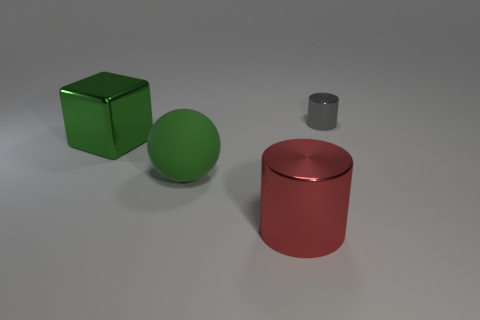The other thing that is the same color as the big rubber thing is what shape?
Ensure brevity in your answer.  Cube. There is a rubber ball; is its color the same as the large metal object behind the large sphere?
Provide a short and direct response. Yes. How many other things are the same size as the matte object?
Your response must be concise. 2. Do the thing that is to the right of the red cylinder and the green rubber object have the same shape?
Ensure brevity in your answer.  No. Is the number of metallic blocks that are on the left side of the green rubber object greater than the number of large cyan objects?
Your response must be concise. Yes. There is a big object that is on the left side of the red shiny thing and on the right side of the green metallic object; what is it made of?
Offer a terse response. Rubber. Is there any other thing that has the same shape as the big green metal thing?
Your response must be concise. No. What number of big green things are both on the right side of the big green metal object and on the left side of the large green ball?
Offer a very short reply. 0. What is the material of the tiny gray object?
Keep it short and to the point. Metal. Are there the same number of green cubes behind the small gray object and tiny cyan shiny cubes?
Provide a short and direct response. Yes. 